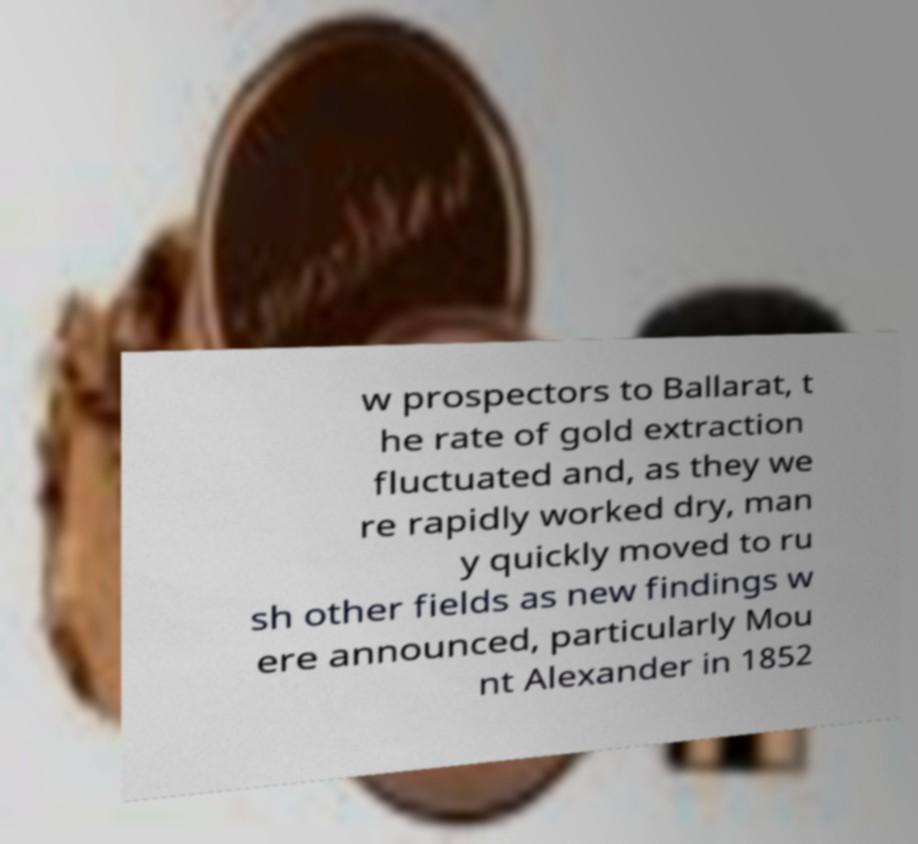Please identify and transcribe the text found in this image. w prospectors to Ballarat, t he rate of gold extraction fluctuated and, as they we re rapidly worked dry, man y quickly moved to ru sh other fields as new findings w ere announced, particularly Mou nt Alexander in 1852 